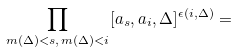Convert formula to latex. <formula><loc_0><loc_0><loc_500><loc_500>\prod _ { m ( \Delta ) < s , \, m ( \Delta ) < i } [ a _ { s } , a _ { i } , \Delta ] ^ { \epsilon ( i , \Delta ) } =</formula> 